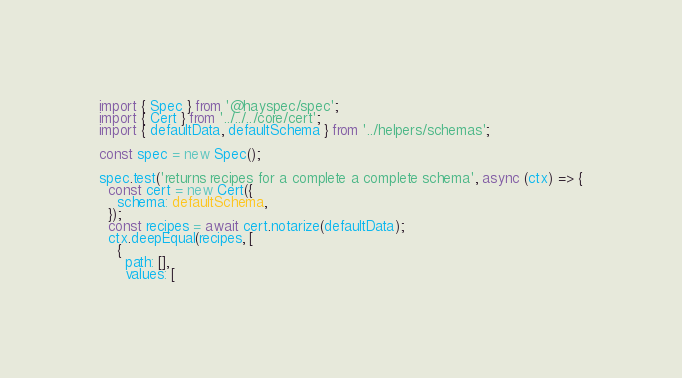Convert code to text. <code><loc_0><loc_0><loc_500><loc_500><_TypeScript_>import { Spec } from '@hayspec/spec';
import { Cert } from '../../../core/cert';
import { defaultData, defaultSchema } from '../helpers/schemas';

const spec = new Spec();

spec.test('returns recipes for a complete a complete schema', async (ctx) => {
  const cert = new Cert({
    schema: defaultSchema,
  });
  const recipes = await cert.notarize(defaultData);
  ctx.deepEqual(recipes, [
    {
      path: [],
      values: [</code> 